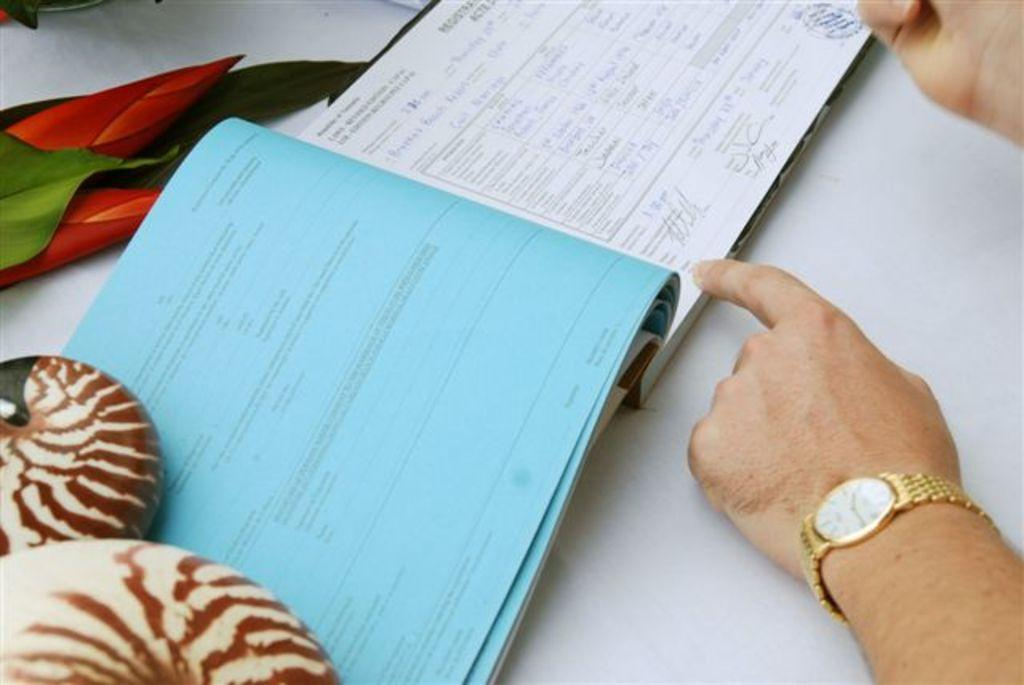What can be seen on the right side of the image? There are hands of a person on the right side of the image. What is the person wearing on their wrist? The person is wearing a golden color watch. What is the color of the watch dial? The watch has a white dial. What is present on a white surface in the image? There is a book on a white surface in the image. What type of flowers are on the left side of the image? There are tulip flowers on the left side of the image. What route does the person take to reach the park in the image? There is no park or route mentioned in the image; it only shows a person's hands, a watch, a book, and tulip flowers. How many arches can be seen in the image? There are no arches present in the image. 